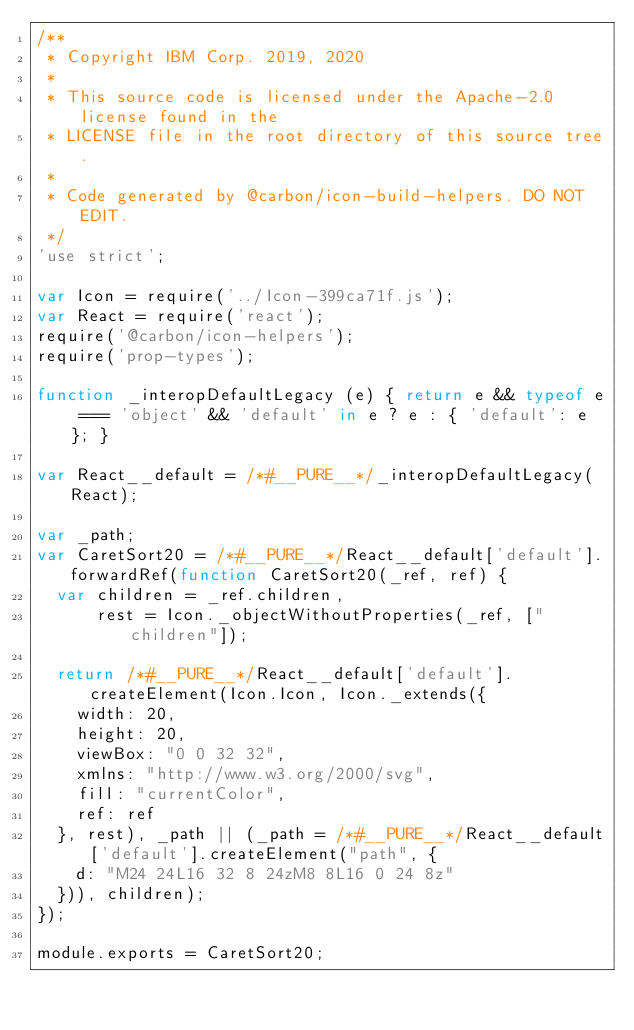<code> <loc_0><loc_0><loc_500><loc_500><_JavaScript_>/**
 * Copyright IBM Corp. 2019, 2020
 *
 * This source code is licensed under the Apache-2.0 license found in the
 * LICENSE file in the root directory of this source tree.
 *
 * Code generated by @carbon/icon-build-helpers. DO NOT EDIT.
 */
'use strict';

var Icon = require('../Icon-399ca71f.js');
var React = require('react');
require('@carbon/icon-helpers');
require('prop-types');

function _interopDefaultLegacy (e) { return e && typeof e === 'object' && 'default' in e ? e : { 'default': e }; }

var React__default = /*#__PURE__*/_interopDefaultLegacy(React);

var _path;
var CaretSort20 = /*#__PURE__*/React__default['default'].forwardRef(function CaretSort20(_ref, ref) {
  var children = _ref.children,
      rest = Icon._objectWithoutProperties(_ref, ["children"]);

  return /*#__PURE__*/React__default['default'].createElement(Icon.Icon, Icon._extends({
    width: 20,
    height: 20,
    viewBox: "0 0 32 32",
    xmlns: "http://www.w3.org/2000/svg",
    fill: "currentColor",
    ref: ref
  }, rest), _path || (_path = /*#__PURE__*/React__default['default'].createElement("path", {
    d: "M24 24L16 32 8 24zM8 8L16 0 24 8z"
  })), children);
});

module.exports = CaretSort20;
</code> 